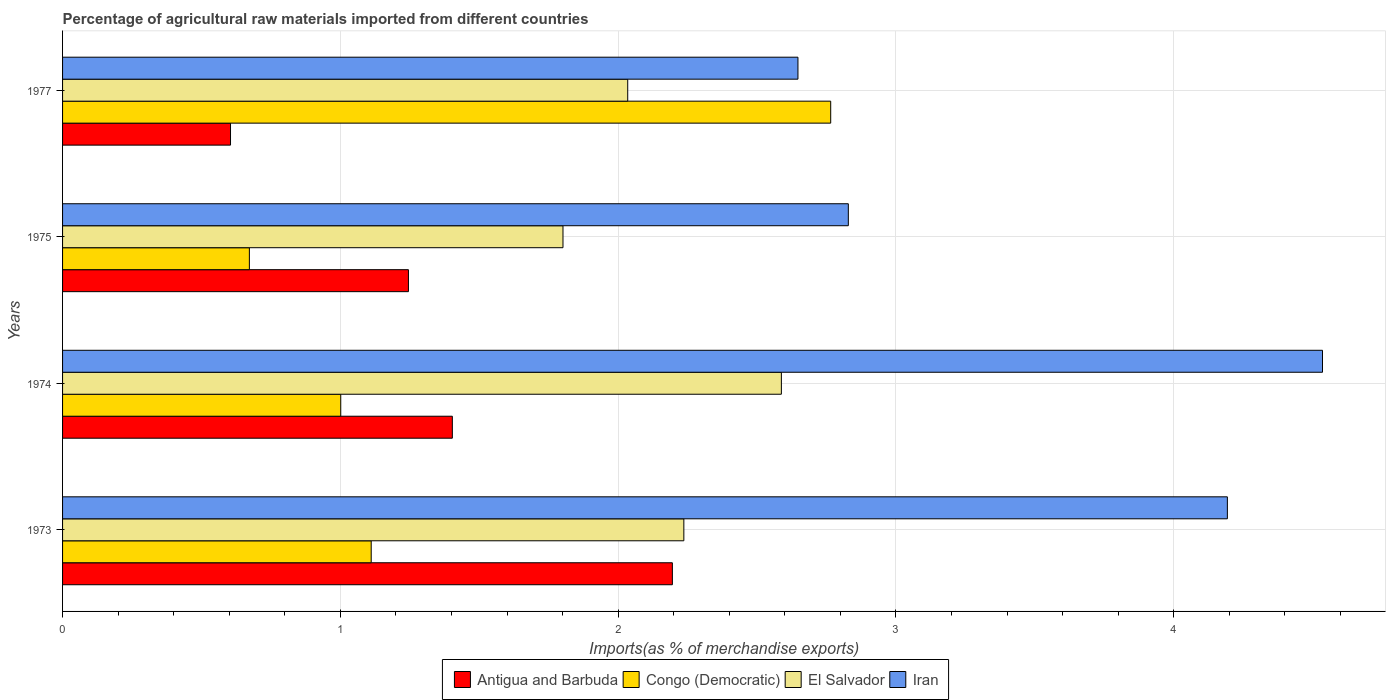How many groups of bars are there?
Give a very brief answer. 4. Are the number of bars on each tick of the Y-axis equal?
Keep it short and to the point. Yes. How many bars are there on the 2nd tick from the top?
Give a very brief answer. 4. What is the label of the 3rd group of bars from the top?
Offer a terse response. 1974. In how many cases, is the number of bars for a given year not equal to the number of legend labels?
Offer a very short reply. 0. What is the percentage of imports to different countries in Congo (Democratic) in 1974?
Keep it short and to the point. 1. Across all years, what is the maximum percentage of imports to different countries in El Salvador?
Ensure brevity in your answer.  2.59. Across all years, what is the minimum percentage of imports to different countries in El Salvador?
Your answer should be compact. 1.8. What is the total percentage of imports to different countries in Iran in the graph?
Your response must be concise. 14.2. What is the difference between the percentage of imports to different countries in Iran in 1973 and that in 1977?
Your answer should be very brief. 1.55. What is the difference between the percentage of imports to different countries in Iran in 1977 and the percentage of imports to different countries in Antigua and Barbuda in 1974?
Offer a very short reply. 1.24. What is the average percentage of imports to different countries in Congo (Democratic) per year?
Keep it short and to the point. 1.39. In the year 1973, what is the difference between the percentage of imports to different countries in Iran and percentage of imports to different countries in Congo (Democratic)?
Your answer should be very brief. 3.08. In how many years, is the percentage of imports to different countries in Antigua and Barbuda greater than 1.6 %?
Provide a succinct answer. 1. What is the ratio of the percentage of imports to different countries in Antigua and Barbuda in 1973 to that in 1977?
Offer a very short reply. 3.63. Is the percentage of imports to different countries in El Salvador in 1974 less than that in 1975?
Ensure brevity in your answer.  No. What is the difference between the highest and the second highest percentage of imports to different countries in Congo (Democratic)?
Keep it short and to the point. 1.65. What is the difference between the highest and the lowest percentage of imports to different countries in Iran?
Your answer should be very brief. 1.89. Is it the case that in every year, the sum of the percentage of imports to different countries in Congo (Democratic) and percentage of imports to different countries in Iran is greater than the sum of percentage of imports to different countries in Antigua and Barbuda and percentage of imports to different countries in El Salvador?
Ensure brevity in your answer.  Yes. What does the 3rd bar from the top in 1977 represents?
Ensure brevity in your answer.  Congo (Democratic). What does the 1st bar from the bottom in 1975 represents?
Offer a terse response. Antigua and Barbuda. Is it the case that in every year, the sum of the percentage of imports to different countries in Iran and percentage of imports to different countries in El Salvador is greater than the percentage of imports to different countries in Antigua and Barbuda?
Give a very brief answer. Yes. How many bars are there?
Ensure brevity in your answer.  16. How many years are there in the graph?
Your answer should be very brief. 4. What is the difference between two consecutive major ticks on the X-axis?
Offer a terse response. 1. How many legend labels are there?
Provide a succinct answer. 4. What is the title of the graph?
Keep it short and to the point. Percentage of agricultural raw materials imported from different countries. What is the label or title of the X-axis?
Your answer should be compact. Imports(as % of merchandise exports). What is the label or title of the Y-axis?
Provide a short and direct response. Years. What is the Imports(as % of merchandise exports) in Antigua and Barbuda in 1973?
Your answer should be compact. 2.2. What is the Imports(as % of merchandise exports) in Congo (Democratic) in 1973?
Your answer should be compact. 1.11. What is the Imports(as % of merchandise exports) in El Salvador in 1973?
Provide a short and direct response. 2.24. What is the Imports(as % of merchandise exports) of Iran in 1973?
Ensure brevity in your answer.  4.19. What is the Imports(as % of merchandise exports) in Antigua and Barbuda in 1974?
Your answer should be very brief. 1.4. What is the Imports(as % of merchandise exports) in Congo (Democratic) in 1974?
Your response must be concise. 1. What is the Imports(as % of merchandise exports) of El Salvador in 1974?
Keep it short and to the point. 2.59. What is the Imports(as % of merchandise exports) of Iran in 1974?
Your answer should be very brief. 4.54. What is the Imports(as % of merchandise exports) in Antigua and Barbuda in 1975?
Offer a terse response. 1.25. What is the Imports(as % of merchandise exports) of Congo (Democratic) in 1975?
Provide a succinct answer. 0.67. What is the Imports(as % of merchandise exports) of El Salvador in 1975?
Ensure brevity in your answer.  1.8. What is the Imports(as % of merchandise exports) of Iran in 1975?
Your answer should be compact. 2.83. What is the Imports(as % of merchandise exports) of Antigua and Barbuda in 1977?
Make the answer very short. 0.6. What is the Imports(as % of merchandise exports) of Congo (Democratic) in 1977?
Ensure brevity in your answer.  2.77. What is the Imports(as % of merchandise exports) of El Salvador in 1977?
Your answer should be very brief. 2.03. What is the Imports(as % of merchandise exports) of Iran in 1977?
Your answer should be compact. 2.65. Across all years, what is the maximum Imports(as % of merchandise exports) in Antigua and Barbuda?
Provide a succinct answer. 2.2. Across all years, what is the maximum Imports(as % of merchandise exports) in Congo (Democratic)?
Offer a terse response. 2.77. Across all years, what is the maximum Imports(as % of merchandise exports) of El Salvador?
Offer a very short reply. 2.59. Across all years, what is the maximum Imports(as % of merchandise exports) in Iran?
Keep it short and to the point. 4.54. Across all years, what is the minimum Imports(as % of merchandise exports) in Antigua and Barbuda?
Make the answer very short. 0.6. Across all years, what is the minimum Imports(as % of merchandise exports) of Congo (Democratic)?
Your response must be concise. 0.67. Across all years, what is the minimum Imports(as % of merchandise exports) of El Salvador?
Give a very brief answer. 1.8. Across all years, what is the minimum Imports(as % of merchandise exports) of Iran?
Provide a succinct answer. 2.65. What is the total Imports(as % of merchandise exports) in Antigua and Barbuda in the graph?
Offer a terse response. 5.45. What is the total Imports(as % of merchandise exports) in Congo (Democratic) in the graph?
Give a very brief answer. 5.55. What is the total Imports(as % of merchandise exports) of El Salvador in the graph?
Keep it short and to the point. 8.66. What is the total Imports(as % of merchandise exports) in Iran in the graph?
Give a very brief answer. 14.2. What is the difference between the Imports(as % of merchandise exports) in Antigua and Barbuda in 1973 and that in 1974?
Your response must be concise. 0.79. What is the difference between the Imports(as % of merchandise exports) of Congo (Democratic) in 1973 and that in 1974?
Provide a succinct answer. 0.11. What is the difference between the Imports(as % of merchandise exports) in El Salvador in 1973 and that in 1974?
Offer a terse response. -0.35. What is the difference between the Imports(as % of merchandise exports) in Iran in 1973 and that in 1974?
Provide a succinct answer. -0.34. What is the difference between the Imports(as % of merchandise exports) of Antigua and Barbuda in 1973 and that in 1975?
Your response must be concise. 0.95. What is the difference between the Imports(as % of merchandise exports) of Congo (Democratic) in 1973 and that in 1975?
Give a very brief answer. 0.44. What is the difference between the Imports(as % of merchandise exports) in El Salvador in 1973 and that in 1975?
Provide a succinct answer. 0.44. What is the difference between the Imports(as % of merchandise exports) in Iran in 1973 and that in 1975?
Offer a very short reply. 1.36. What is the difference between the Imports(as % of merchandise exports) in Antigua and Barbuda in 1973 and that in 1977?
Give a very brief answer. 1.59. What is the difference between the Imports(as % of merchandise exports) of Congo (Democratic) in 1973 and that in 1977?
Offer a terse response. -1.65. What is the difference between the Imports(as % of merchandise exports) of El Salvador in 1973 and that in 1977?
Your answer should be very brief. 0.2. What is the difference between the Imports(as % of merchandise exports) of Iran in 1973 and that in 1977?
Your answer should be very brief. 1.55. What is the difference between the Imports(as % of merchandise exports) of Antigua and Barbuda in 1974 and that in 1975?
Provide a short and direct response. 0.16. What is the difference between the Imports(as % of merchandise exports) of Congo (Democratic) in 1974 and that in 1975?
Offer a very short reply. 0.33. What is the difference between the Imports(as % of merchandise exports) in El Salvador in 1974 and that in 1975?
Offer a terse response. 0.79. What is the difference between the Imports(as % of merchandise exports) of Iran in 1974 and that in 1975?
Provide a short and direct response. 1.71. What is the difference between the Imports(as % of merchandise exports) in Antigua and Barbuda in 1974 and that in 1977?
Make the answer very short. 0.8. What is the difference between the Imports(as % of merchandise exports) in Congo (Democratic) in 1974 and that in 1977?
Keep it short and to the point. -1.76. What is the difference between the Imports(as % of merchandise exports) of El Salvador in 1974 and that in 1977?
Ensure brevity in your answer.  0.55. What is the difference between the Imports(as % of merchandise exports) in Iran in 1974 and that in 1977?
Offer a terse response. 1.89. What is the difference between the Imports(as % of merchandise exports) of Antigua and Barbuda in 1975 and that in 1977?
Offer a very short reply. 0.64. What is the difference between the Imports(as % of merchandise exports) in Congo (Democratic) in 1975 and that in 1977?
Give a very brief answer. -2.09. What is the difference between the Imports(as % of merchandise exports) of El Salvador in 1975 and that in 1977?
Keep it short and to the point. -0.23. What is the difference between the Imports(as % of merchandise exports) in Iran in 1975 and that in 1977?
Your answer should be very brief. 0.18. What is the difference between the Imports(as % of merchandise exports) in Antigua and Barbuda in 1973 and the Imports(as % of merchandise exports) in Congo (Democratic) in 1974?
Offer a very short reply. 1.19. What is the difference between the Imports(as % of merchandise exports) in Antigua and Barbuda in 1973 and the Imports(as % of merchandise exports) in El Salvador in 1974?
Give a very brief answer. -0.39. What is the difference between the Imports(as % of merchandise exports) of Antigua and Barbuda in 1973 and the Imports(as % of merchandise exports) of Iran in 1974?
Give a very brief answer. -2.34. What is the difference between the Imports(as % of merchandise exports) of Congo (Democratic) in 1973 and the Imports(as % of merchandise exports) of El Salvador in 1974?
Keep it short and to the point. -1.48. What is the difference between the Imports(as % of merchandise exports) of Congo (Democratic) in 1973 and the Imports(as % of merchandise exports) of Iran in 1974?
Keep it short and to the point. -3.42. What is the difference between the Imports(as % of merchandise exports) of El Salvador in 1973 and the Imports(as % of merchandise exports) of Iran in 1974?
Provide a short and direct response. -2.3. What is the difference between the Imports(as % of merchandise exports) in Antigua and Barbuda in 1973 and the Imports(as % of merchandise exports) in Congo (Democratic) in 1975?
Provide a short and direct response. 1.52. What is the difference between the Imports(as % of merchandise exports) in Antigua and Barbuda in 1973 and the Imports(as % of merchandise exports) in El Salvador in 1975?
Make the answer very short. 0.39. What is the difference between the Imports(as % of merchandise exports) of Antigua and Barbuda in 1973 and the Imports(as % of merchandise exports) of Iran in 1975?
Your answer should be compact. -0.63. What is the difference between the Imports(as % of merchandise exports) of Congo (Democratic) in 1973 and the Imports(as % of merchandise exports) of El Salvador in 1975?
Your response must be concise. -0.69. What is the difference between the Imports(as % of merchandise exports) in Congo (Democratic) in 1973 and the Imports(as % of merchandise exports) in Iran in 1975?
Offer a very short reply. -1.72. What is the difference between the Imports(as % of merchandise exports) of El Salvador in 1973 and the Imports(as % of merchandise exports) of Iran in 1975?
Provide a short and direct response. -0.59. What is the difference between the Imports(as % of merchandise exports) in Antigua and Barbuda in 1973 and the Imports(as % of merchandise exports) in Congo (Democratic) in 1977?
Keep it short and to the point. -0.57. What is the difference between the Imports(as % of merchandise exports) in Antigua and Barbuda in 1973 and the Imports(as % of merchandise exports) in El Salvador in 1977?
Offer a terse response. 0.16. What is the difference between the Imports(as % of merchandise exports) of Antigua and Barbuda in 1973 and the Imports(as % of merchandise exports) of Iran in 1977?
Provide a succinct answer. -0.45. What is the difference between the Imports(as % of merchandise exports) in Congo (Democratic) in 1973 and the Imports(as % of merchandise exports) in El Salvador in 1977?
Provide a short and direct response. -0.92. What is the difference between the Imports(as % of merchandise exports) of Congo (Democratic) in 1973 and the Imports(as % of merchandise exports) of Iran in 1977?
Provide a short and direct response. -1.54. What is the difference between the Imports(as % of merchandise exports) of El Salvador in 1973 and the Imports(as % of merchandise exports) of Iran in 1977?
Provide a short and direct response. -0.41. What is the difference between the Imports(as % of merchandise exports) in Antigua and Barbuda in 1974 and the Imports(as % of merchandise exports) in Congo (Democratic) in 1975?
Make the answer very short. 0.73. What is the difference between the Imports(as % of merchandise exports) of Antigua and Barbuda in 1974 and the Imports(as % of merchandise exports) of El Salvador in 1975?
Your response must be concise. -0.4. What is the difference between the Imports(as % of merchandise exports) of Antigua and Barbuda in 1974 and the Imports(as % of merchandise exports) of Iran in 1975?
Offer a very short reply. -1.43. What is the difference between the Imports(as % of merchandise exports) in Congo (Democratic) in 1974 and the Imports(as % of merchandise exports) in Iran in 1975?
Your answer should be compact. -1.83. What is the difference between the Imports(as % of merchandise exports) of El Salvador in 1974 and the Imports(as % of merchandise exports) of Iran in 1975?
Your answer should be very brief. -0.24. What is the difference between the Imports(as % of merchandise exports) of Antigua and Barbuda in 1974 and the Imports(as % of merchandise exports) of Congo (Democratic) in 1977?
Offer a terse response. -1.36. What is the difference between the Imports(as % of merchandise exports) of Antigua and Barbuda in 1974 and the Imports(as % of merchandise exports) of El Salvador in 1977?
Give a very brief answer. -0.63. What is the difference between the Imports(as % of merchandise exports) in Antigua and Barbuda in 1974 and the Imports(as % of merchandise exports) in Iran in 1977?
Ensure brevity in your answer.  -1.24. What is the difference between the Imports(as % of merchandise exports) of Congo (Democratic) in 1974 and the Imports(as % of merchandise exports) of El Salvador in 1977?
Your answer should be very brief. -1.03. What is the difference between the Imports(as % of merchandise exports) of Congo (Democratic) in 1974 and the Imports(as % of merchandise exports) of Iran in 1977?
Make the answer very short. -1.65. What is the difference between the Imports(as % of merchandise exports) of El Salvador in 1974 and the Imports(as % of merchandise exports) of Iran in 1977?
Provide a succinct answer. -0.06. What is the difference between the Imports(as % of merchandise exports) of Antigua and Barbuda in 1975 and the Imports(as % of merchandise exports) of Congo (Democratic) in 1977?
Make the answer very short. -1.52. What is the difference between the Imports(as % of merchandise exports) in Antigua and Barbuda in 1975 and the Imports(as % of merchandise exports) in El Salvador in 1977?
Provide a short and direct response. -0.79. What is the difference between the Imports(as % of merchandise exports) of Antigua and Barbuda in 1975 and the Imports(as % of merchandise exports) of Iran in 1977?
Provide a succinct answer. -1.4. What is the difference between the Imports(as % of merchandise exports) of Congo (Democratic) in 1975 and the Imports(as % of merchandise exports) of El Salvador in 1977?
Your answer should be compact. -1.36. What is the difference between the Imports(as % of merchandise exports) in Congo (Democratic) in 1975 and the Imports(as % of merchandise exports) in Iran in 1977?
Ensure brevity in your answer.  -1.97. What is the difference between the Imports(as % of merchandise exports) of El Salvador in 1975 and the Imports(as % of merchandise exports) of Iran in 1977?
Make the answer very short. -0.85. What is the average Imports(as % of merchandise exports) in Antigua and Barbuda per year?
Offer a terse response. 1.36. What is the average Imports(as % of merchandise exports) of Congo (Democratic) per year?
Your answer should be compact. 1.39. What is the average Imports(as % of merchandise exports) of El Salvador per year?
Your response must be concise. 2.17. What is the average Imports(as % of merchandise exports) of Iran per year?
Your answer should be very brief. 3.55. In the year 1973, what is the difference between the Imports(as % of merchandise exports) of Antigua and Barbuda and Imports(as % of merchandise exports) of Congo (Democratic)?
Make the answer very short. 1.08. In the year 1973, what is the difference between the Imports(as % of merchandise exports) in Antigua and Barbuda and Imports(as % of merchandise exports) in El Salvador?
Offer a terse response. -0.04. In the year 1973, what is the difference between the Imports(as % of merchandise exports) in Antigua and Barbuda and Imports(as % of merchandise exports) in Iran?
Offer a terse response. -2. In the year 1973, what is the difference between the Imports(as % of merchandise exports) in Congo (Democratic) and Imports(as % of merchandise exports) in El Salvador?
Your answer should be very brief. -1.13. In the year 1973, what is the difference between the Imports(as % of merchandise exports) of Congo (Democratic) and Imports(as % of merchandise exports) of Iran?
Your answer should be compact. -3.08. In the year 1973, what is the difference between the Imports(as % of merchandise exports) of El Salvador and Imports(as % of merchandise exports) of Iran?
Give a very brief answer. -1.96. In the year 1974, what is the difference between the Imports(as % of merchandise exports) in Antigua and Barbuda and Imports(as % of merchandise exports) in Congo (Democratic)?
Ensure brevity in your answer.  0.4. In the year 1974, what is the difference between the Imports(as % of merchandise exports) in Antigua and Barbuda and Imports(as % of merchandise exports) in El Salvador?
Offer a terse response. -1.18. In the year 1974, what is the difference between the Imports(as % of merchandise exports) in Antigua and Barbuda and Imports(as % of merchandise exports) in Iran?
Make the answer very short. -3.13. In the year 1974, what is the difference between the Imports(as % of merchandise exports) of Congo (Democratic) and Imports(as % of merchandise exports) of El Salvador?
Give a very brief answer. -1.59. In the year 1974, what is the difference between the Imports(as % of merchandise exports) in Congo (Democratic) and Imports(as % of merchandise exports) in Iran?
Your answer should be compact. -3.53. In the year 1974, what is the difference between the Imports(as % of merchandise exports) of El Salvador and Imports(as % of merchandise exports) of Iran?
Give a very brief answer. -1.95. In the year 1975, what is the difference between the Imports(as % of merchandise exports) of Antigua and Barbuda and Imports(as % of merchandise exports) of Congo (Democratic)?
Provide a short and direct response. 0.57. In the year 1975, what is the difference between the Imports(as % of merchandise exports) in Antigua and Barbuda and Imports(as % of merchandise exports) in El Salvador?
Your answer should be compact. -0.56. In the year 1975, what is the difference between the Imports(as % of merchandise exports) in Antigua and Barbuda and Imports(as % of merchandise exports) in Iran?
Your answer should be very brief. -1.58. In the year 1975, what is the difference between the Imports(as % of merchandise exports) in Congo (Democratic) and Imports(as % of merchandise exports) in El Salvador?
Your response must be concise. -1.13. In the year 1975, what is the difference between the Imports(as % of merchandise exports) in Congo (Democratic) and Imports(as % of merchandise exports) in Iran?
Your answer should be compact. -2.16. In the year 1975, what is the difference between the Imports(as % of merchandise exports) in El Salvador and Imports(as % of merchandise exports) in Iran?
Offer a very short reply. -1.03. In the year 1977, what is the difference between the Imports(as % of merchandise exports) of Antigua and Barbuda and Imports(as % of merchandise exports) of Congo (Democratic)?
Your answer should be very brief. -2.16. In the year 1977, what is the difference between the Imports(as % of merchandise exports) of Antigua and Barbuda and Imports(as % of merchandise exports) of El Salvador?
Provide a short and direct response. -1.43. In the year 1977, what is the difference between the Imports(as % of merchandise exports) in Antigua and Barbuda and Imports(as % of merchandise exports) in Iran?
Provide a succinct answer. -2.04. In the year 1977, what is the difference between the Imports(as % of merchandise exports) of Congo (Democratic) and Imports(as % of merchandise exports) of El Salvador?
Ensure brevity in your answer.  0.73. In the year 1977, what is the difference between the Imports(as % of merchandise exports) of Congo (Democratic) and Imports(as % of merchandise exports) of Iran?
Your response must be concise. 0.12. In the year 1977, what is the difference between the Imports(as % of merchandise exports) in El Salvador and Imports(as % of merchandise exports) in Iran?
Give a very brief answer. -0.61. What is the ratio of the Imports(as % of merchandise exports) of Antigua and Barbuda in 1973 to that in 1974?
Offer a terse response. 1.56. What is the ratio of the Imports(as % of merchandise exports) of Congo (Democratic) in 1973 to that in 1974?
Provide a short and direct response. 1.11. What is the ratio of the Imports(as % of merchandise exports) of El Salvador in 1973 to that in 1974?
Provide a short and direct response. 0.86. What is the ratio of the Imports(as % of merchandise exports) in Iran in 1973 to that in 1974?
Provide a short and direct response. 0.92. What is the ratio of the Imports(as % of merchandise exports) in Antigua and Barbuda in 1973 to that in 1975?
Make the answer very short. 1.76. What is the ratio of the Imports(as % of merchandise exports) in Congo (Democratic) in 1973 to that in 1975?
Keep it short and to the point. 1.65. What is the ratio of the Imports(as % of merchandise exports) of El Salvador in 1973 to that in 1975?
Offer a very short reply. 1.24. What is the ratio of the Imports(as % of merchandise exports) in Iran in 1973 to that in 1975?
Your answer should be very brief. 1.48. What is the ratio of the Imports(as % of merchandise exports) of Antigua and Barbuda in 1973 to that in 1977?
Provide a short and direct response. 3.63. What is the ratio of the Imports(as % of merchandise exports) in Congo (Democratic) in 1973 to that in 1977?
Ensure brevity in your answer.  0.4. What is the ratio of the Imports(as % of merchandise exports) in El Salvador in 1973 to that in 1977?
Offer a terse response. 1.1. What is the ratio of the Imports(as % of merchandise exports) of Iran in 1973 to that in 1977?
Offer a very short reply. 1.58. What is the ratio of the Imports(as % of merchandise exports) in Antigua and Barbuda in 1974 to that in 1975?
Offer a terse response. 1.13. What is the ratio of the Imports(as % of merchandise exports) in Congo (Democratic) in 1974 to that in 1975?
Provide a short and direct response. 1.49. What is the ratio of the Imports(as % of merchandise exports) of El Salvador in 1974 to that in 1975?
Give a very brief answer. 1.44. What is the ratio of the Imports(as % of merchandise exports) of Iran in 1974 to that in 1975?
Offer a very short reply. 1.6. What is the ratio of the Imports(as % of merchandise exports) in Antigua and Barbuda in 1974 to that in 1977?
Your answer should be very brief. 2.32. What is the ratio of the Imports(as % of merchandise exports) of Congo (Democratic) in 1974 to that in 1977?
Your response must be concise. 0.36. What is the ratio of the Imports(as % of merchandise exports) of El Salvador in 1974 to that in 1977?
Your response must be concise. 1.27. What is the ratio of the Imports(as % of merchandise exports) in Iran in 1974 to that in 1977?
Provide a short and direct response. 1.71. What is the ratio of the Imports(as % of merchandise exports) of Antigua and Barbuda in 1975 to that in 1977?
Provide a succinct answer. 2.06. What is the ratio of the Imports(as % of merchandise exports) of Congo (Democratic) in 1975 to that in 1977?
Your answer should be very brief. 0.24. What is the ratio of the Imports(as % of merchandise exports) of El Salvador in 1975 to that in 1977?
Make the answer very short. 0.89. What is the ratio of the Imports(as % of merchandise exports) of Iran in 1975 to that in 1977?
Offer a very short reply. 1.07. What is the difference between the highest and the second highest Imports(as % of merchandise exports) of Antigua and Barbuda?
Offer a very short reply. 0.79. What is the difference between the highest and the second highest Imports(as % of merchandise exports) of Congo (Democratic)?
Give a very brief answer. 1.65. What is the difference between the highest and the second highest Imports(as % of merchandise exports) in El Salvador?
Your answer should be very brief. 0.35. What is the difference between the highest and the second highest Imports(as % of merchandise exports) in Iran?
Your answer should be very brief. 0.34. What is the difference between the highest and the lowest Imports(as % of merchandise exports) in Antigua and Barbuda?
Keep it short and to the point. 1.59. What is the difference between the highest and the lowest Imports(as % of merchandise exports) of Congo (Democratic)?
Offer a terse response. 2.09. What is the difference between the highest and the lowest Imports(as % of merchandise exports) of El Salvador?
Your response must be concise. 0.79. What is the difference between the highest and the lowest Imports(as % of merchandise exports) in Iran?
Provide a succinct answer. 1.89. 